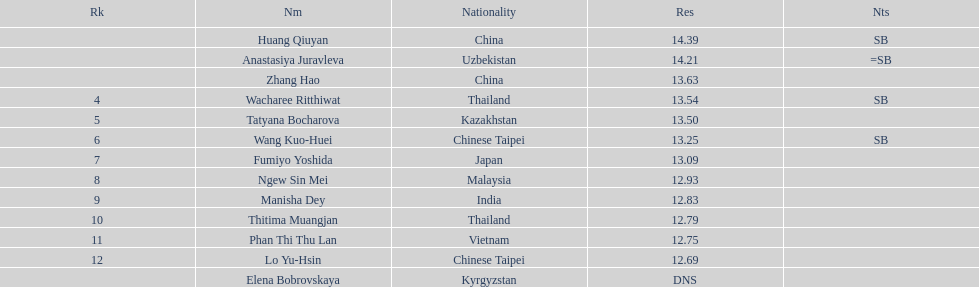How many athletes had a better result than tatyana bocharova? 4. 